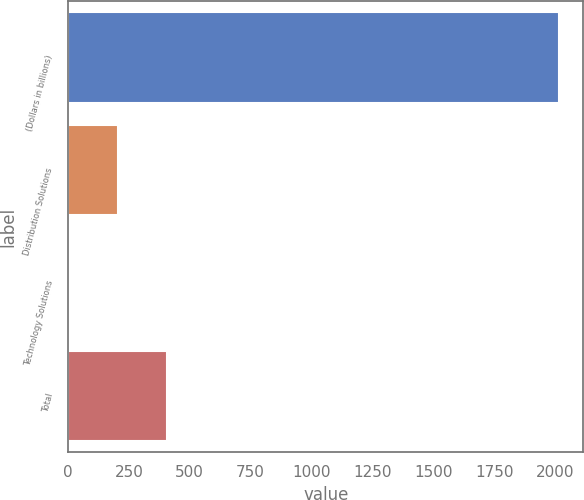<chart> <loc_0><loc_0><loc_500><loc_500><bar_chart><fcel>(Dollars in billions)<fcel>Distribution Solutions<fcel>Technology Solutions<fcel>Total<nl><fcel>2016<fcel>204.21<fcel>2.9<fcel>405.52<nl></chart> 